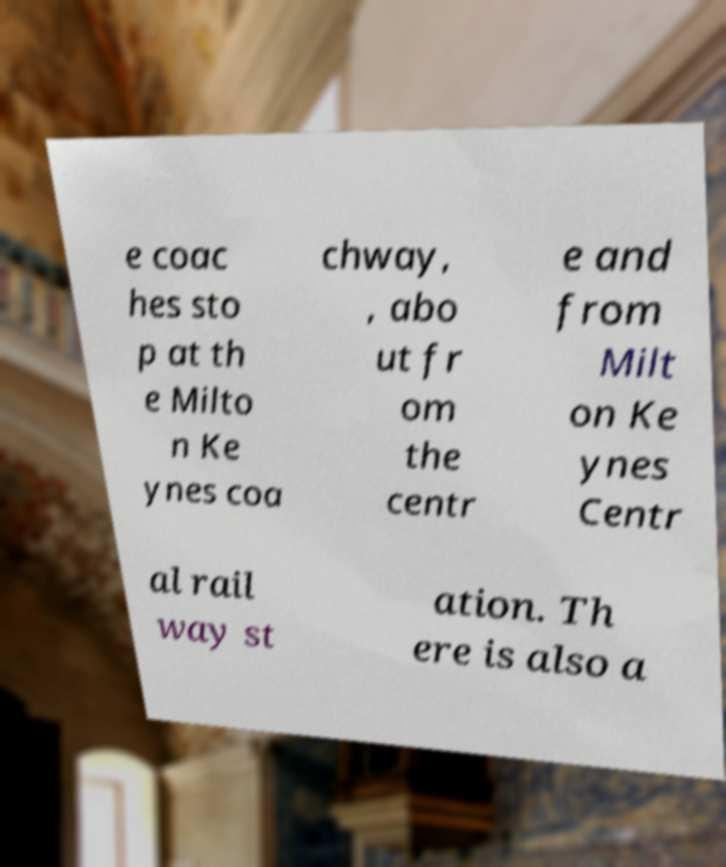For documentation purposes, I need the text within this image transcribed. Could you provide that? e coac hes sto p at th e Milto n Ke ynes coa chway, , abo ut fr om the centr e and from Milt on Ke ynes Centr al rail way st ation. Th ere is also a 